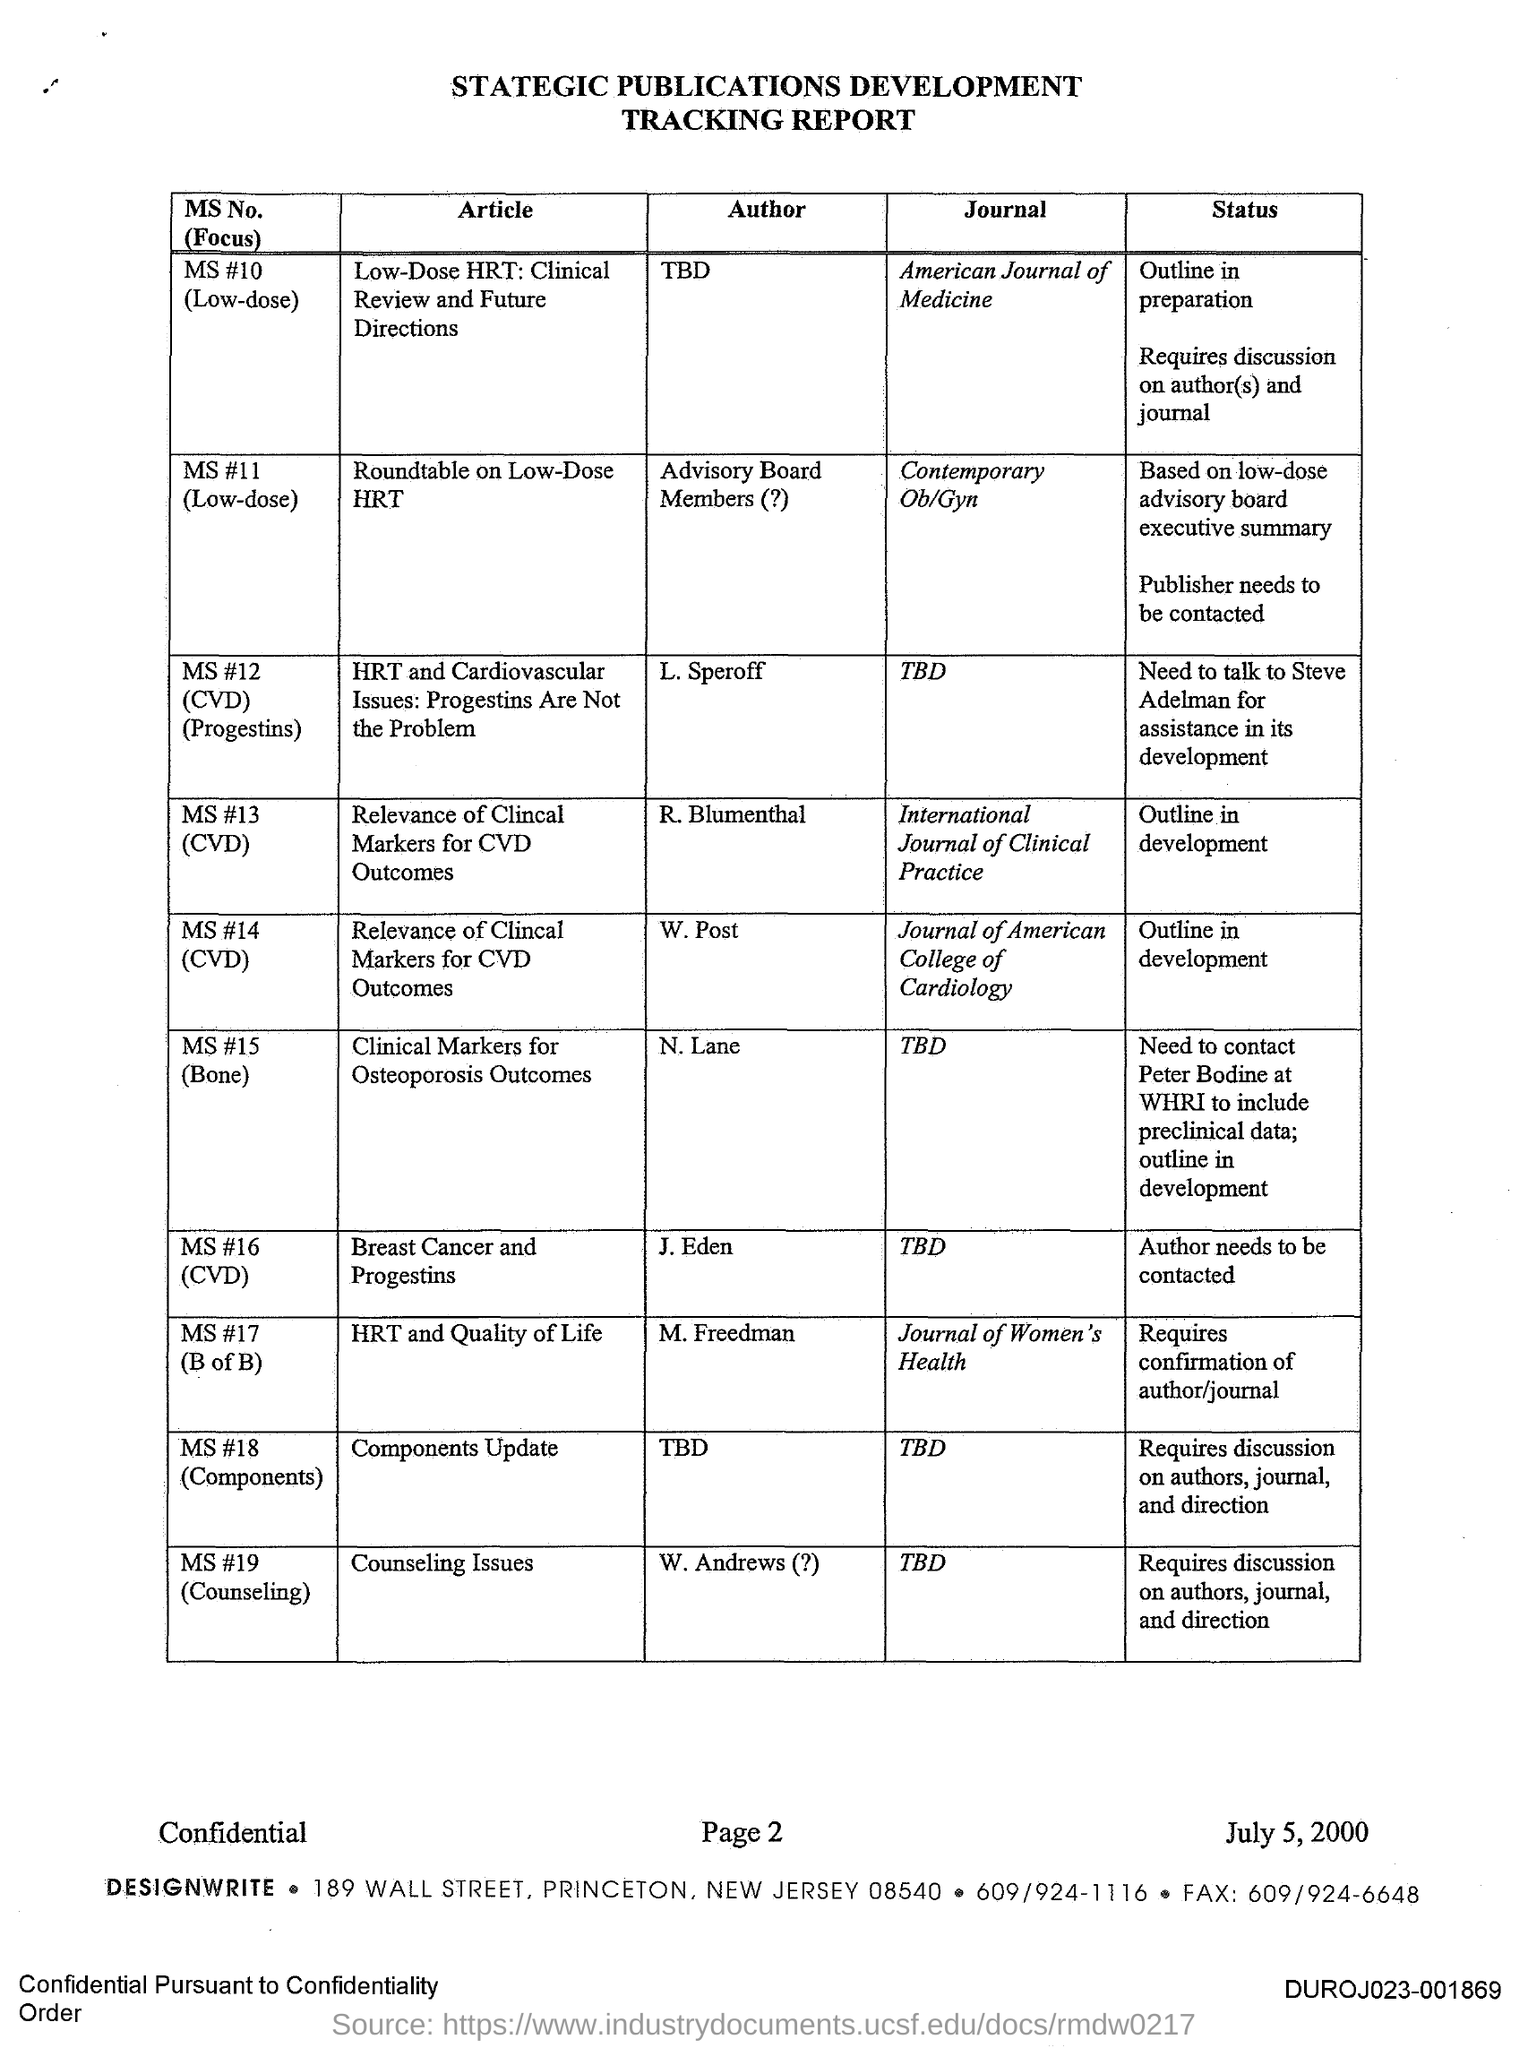Can you tell me more about the document and its purpose? The document appears to be a 'Strategic Publications Development Tracking Report' dated July 5, 2000, from DesignWrite, based in Princeton, NJ. It contains a list of manuscripts with their titles, authors, intended journals, and publication status, suggesting it's used for managing and tracking the progress of various articles through different stages of development and publishing, likely within a medical or scientific context. 